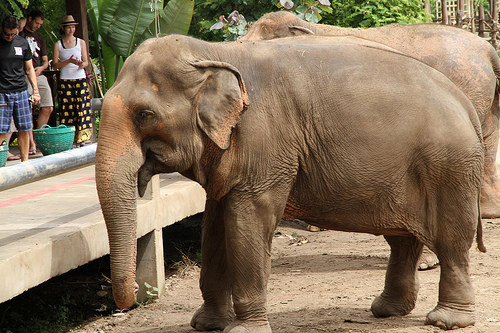Is the girl to the left or to the right of the man that is wearing a tee shirt? The girl is to the right of the man who is wearing a t-shirt. 